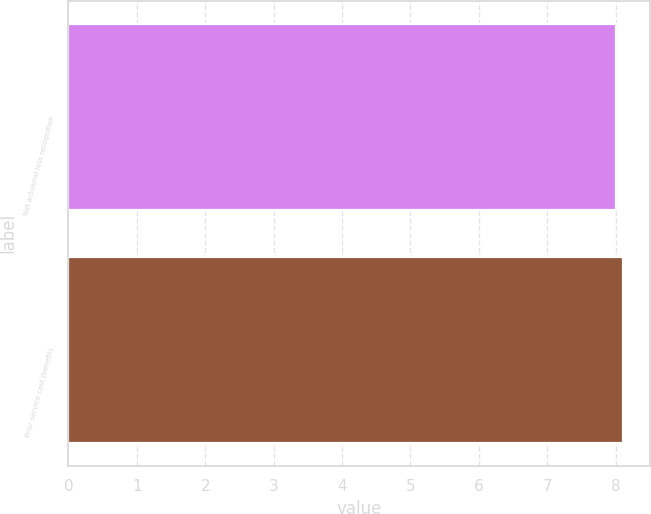Convert chart to OTSL. <chart><loc_0><loc_0><loc_500><loc_500><bar_chart><fcel>Net actuarial loss recognition<fcel>Prior service cost (benefit)<nl><fcel>8<fcel>8.1<nl></chart> 